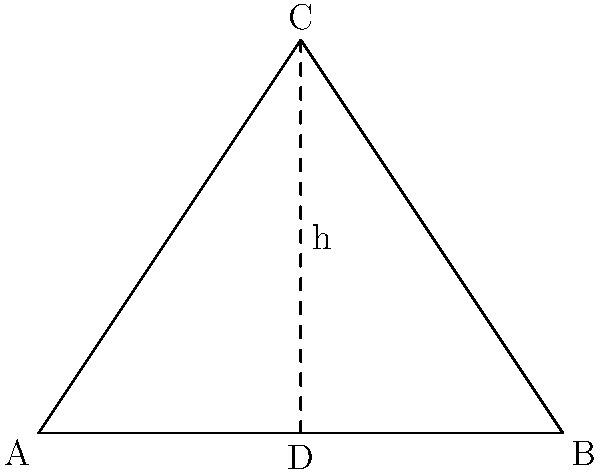In a triangular military formation, soldiers are positioned at points A, B, and C, forming an isosceles triangle. If the base of the triangle (AB) is 40 meters long and the height (CD) is 30 meters, what is the total distance a soldier would need to travel to walk around the perimeter of this formation? To solve this problem, we need to follow these steps:

1) First, we need to find the length of the two equal sides (AC and BC) of the isosceles triangle.

2) We can use the Pythagorean theorem to do this. In the right triangle ACD:

   $AC^2 = AD^2 + CD^2$

3) We know CD (height) is 30 meters, and AD is half of AB, which is 20 meters.

4) Plugging these values into the equation:

   $AC^2 = 20^2 + 30^2 = 400 + 900 = 1300$

5) Taking the square root of both sides:

   $AC = \sqrt{1300} = 10\sqrt{13}$ meters

6) Since the triangle is isosceles, BC is also $10\sqrt{13}$ meters.

7) Now, to find the perimeter, we add all three sides:

   Perimeter $= AB + AC + BC = 40 + 10\sqrt{13} + 10\sqrt{13} = 40 + 20\sqrt{13}$ meters

Therefore, a soldier would need to travel $40 + 20\sqrt{13}$ meters to walk around the perimeter of this formation.
Answer: $40 + 20\sqrt{13}$ meters 